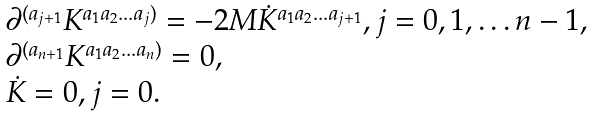Convert formula to latex. <formula><loc_0><loc_0><loc_500><loc_500>\begin{array} { l } \partial ^ { ( a _ { j + 1 } } K ^ { a _ { 1 } a _ { 2 } \dots a _ { j } ) } = - 2 M { \dot { K } } ^ { a _ { 1 } a _ { 2 } \dots a _ { j + 1 } } , j = 0 , 1 , \dots n - 1 , \\ \partial ^ { ( a _ { n + 1 } } K ^ { a _ { 1 } a _ { 2 } \dots a _ { n } ) } = 0 , \\ { \dot { K } } = 0 , j = 0 . \end{array}</formula> 